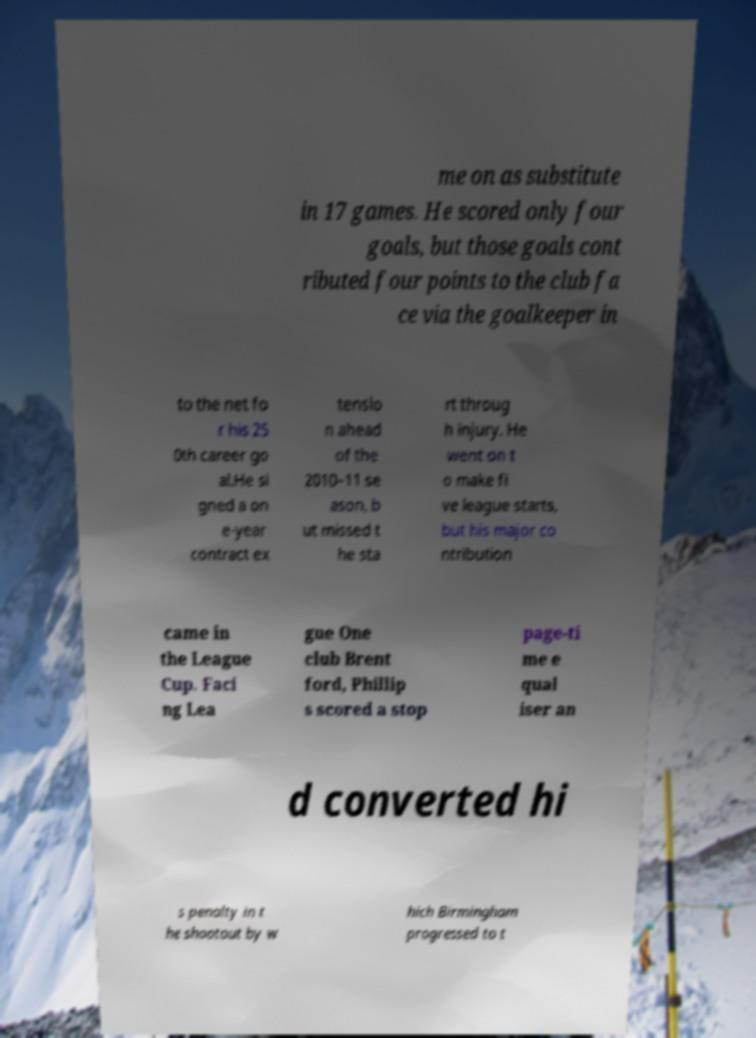Please identify and transcribe the text found in this image. me on as substitute in 17 games. He scored only four goals, but those goals cont ributed four points to the club fa ce via the goalkeeper in to the net fo r his 25 0th career go al.He si gned a on e-year contract ex tensio n ahead of the 2010–11 se ason, b ut missed t he sta rt throug h injury. He went on t o make fi ve league starts, but his major co ntribution came in the League Cup. Faci ng Lea gue One club Brent ford, Phillip s scored a stop page-ti me e qual iser an d converted hi s penalty in t he shootout by w hich Birmingham progressed to t 